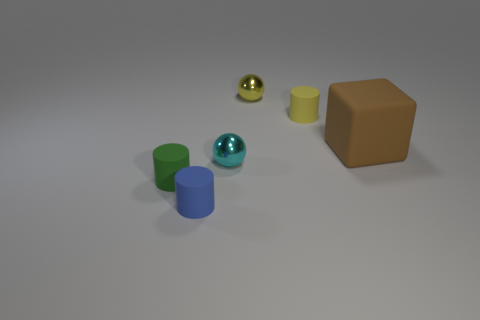Add 2 small cyan spheres. How many objects exist? 8 Subtract 1 spheres. How many spheres are left? 1 Subtract all blue cylinders. How many cylinders are left? 2 Subtract all blocks. How many objects are left? 5 Subtract all large blue matte cylinders. Subtract all blue cylinders. How many objects are left? 5 Add 4 yellow cylinders. How many yellow cylinders are left? 5 Add 2 green cylinders. How many green cylinders exist? 3 Subtract 1 cyan balls. How many objects are left? 5 Subtract all gray cylinders. Subtract all purple blocks. How many cylinders are left? 3 Subtract all green cubes. How many green cylinders are left? 1 